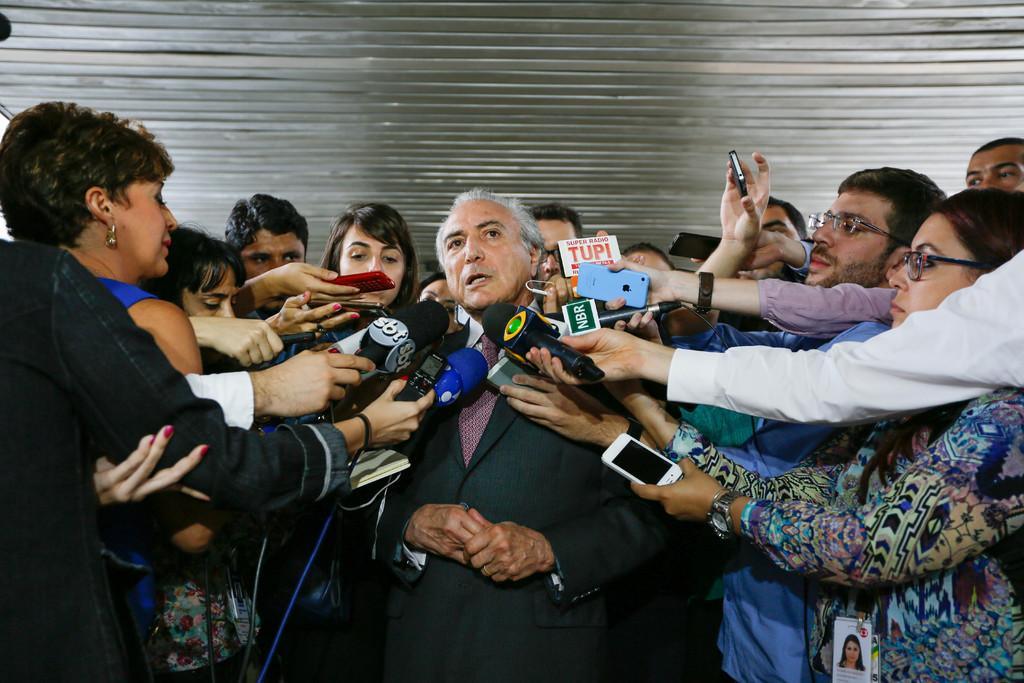How would you summarize this image in a sentence or two? In the picture a person is being interviewed by a lot of journalists,there are plenty of mics,mobile recorders around the person. 